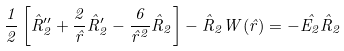<formula> <loc_0><loc_0><loc_500><loc_500>\frac { 1 } { 2 } \left [ \hat { R } _ { 2 } ^ { \prime \prime } + \frac { 2 } { \hat { r } } \hat { R } _ { 2 } ^ { \prime } - \frac { 6 } { \hat { r } ^ { 2 } } \hat { R } _ { 2 } \right ] - \hat { R } _ { 2 } W ( \hat { r } ) = - \hat { E _ { 2 } } \hat { R } _ { 2 }</formula> 